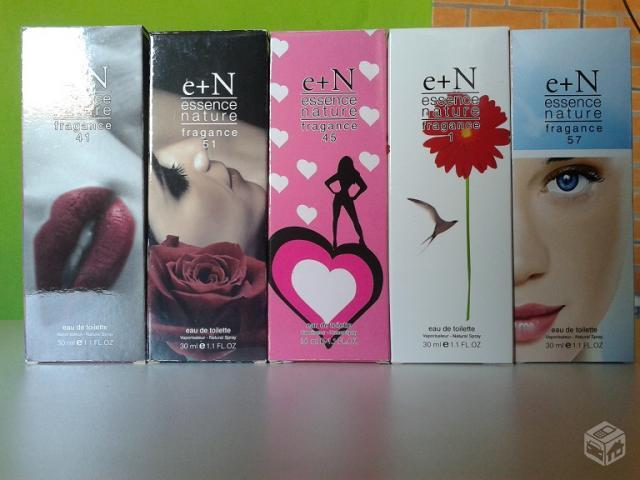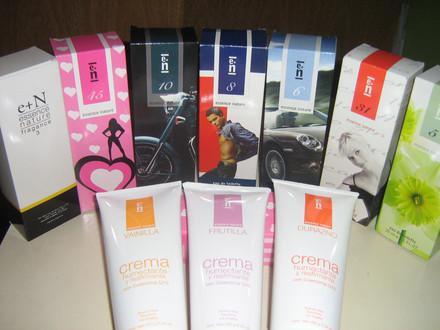The first image is the image on the left, the second image is the image on the right. Considering the images on both sides, is "One image shows a slender bottle upright next to a box with half of a woman's face on it's front." valid? Answer yes or no. No. The first image is the image on the left, the second image is the image on the right. Given the left and right images, does the statement "One of the product boxes has a red flower on the front." hold true? Answer yes or no. Yes. 